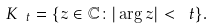<formula> <loc_0><loc_0><loc_500><loc_500>K _ { \ t } = \{ z \in \mathbb { C } \colon | \arg z | < \ t \} .</formula> 